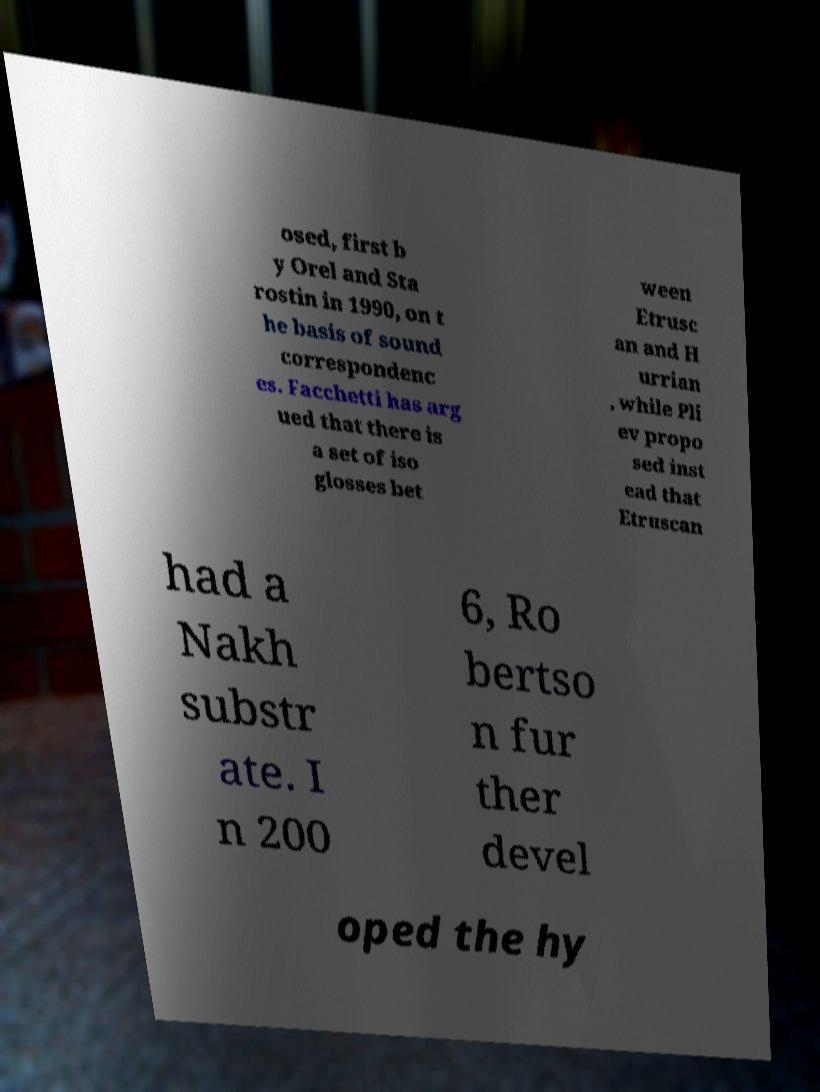Could you extract and type out the text from this image? osed, first b y Orel and Sta rostin in 1990, on t he basis of sound correspondenc es. Facchetti has arg ued that there is a set of iso glosses bet ween Etrusc an and H urrian , while Pli ev propo sed inst ead that Etruscan had a Nakh substr ate. I n 200 6, Ro bertso n fur ther devel oped the hy 